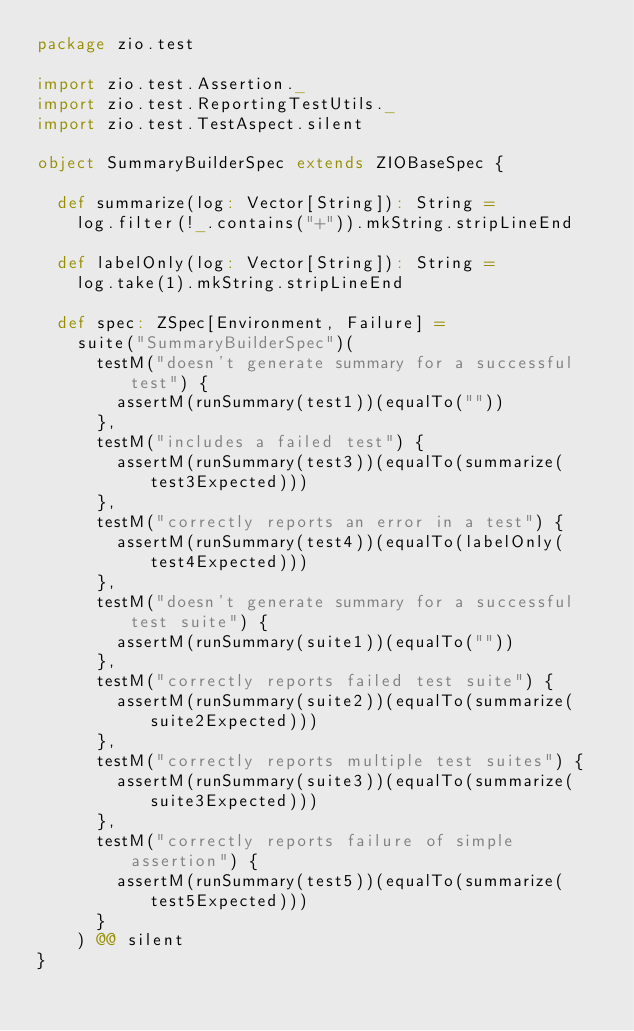Convert code to text. <code><loc_0><loc_0><loc_500><loc_500><_Scala_>package zio.test

import zio.test.Assertion._
import zio.test.ReportingTestUtils._
import zio.test.TestAspect.silent

object SummaryBuilderSpec extends ZIOBaseSpec {

  def summarize(log: Vector[String]): String =
    log.filter(!_.contains("+")).mkString.stripLineEnd

  def labelOnly(log: Vector[String]): String =
    log.take(1).mkString.stripLineEnd

  def spec: ZSpec[Environment, Failure] =
    suite("SummaryBuilderSpec")(
      testM("doesn't generate summary for a successful test") {
        assertM(runSummary(test1))(equalTo(""))
      },
      testM("includes a failed test") {
        assertM(runSummary(test3))(equalTo(summarize(test3Expected)))
      },
      testM("correctly reports an error in a test") {
        assertM(runSummary(test4))(equalTo(labelOnly(test4Expected)))
      },
      testM("doesn't generate summary for a successful test suite") {
        assertM(runSummary(suite1))(equalTo(""))
      },
      testM("correctly reports failed test suite") {
        assertM(runSummary(suite2))(equalTo(summarize(suite2Expected)))
      },
      testM("correctly reports multiple test suites") {
        assertM(runSummary(suite3))(equalTo(summarize(suite3Expected)))
      },
      testM("correctly reports failure of simple assertion") {
        assertM(runSummary(test5))(equalTo(summarize(test5Expected)))
      }
    ) @@ silent
}
</code> 